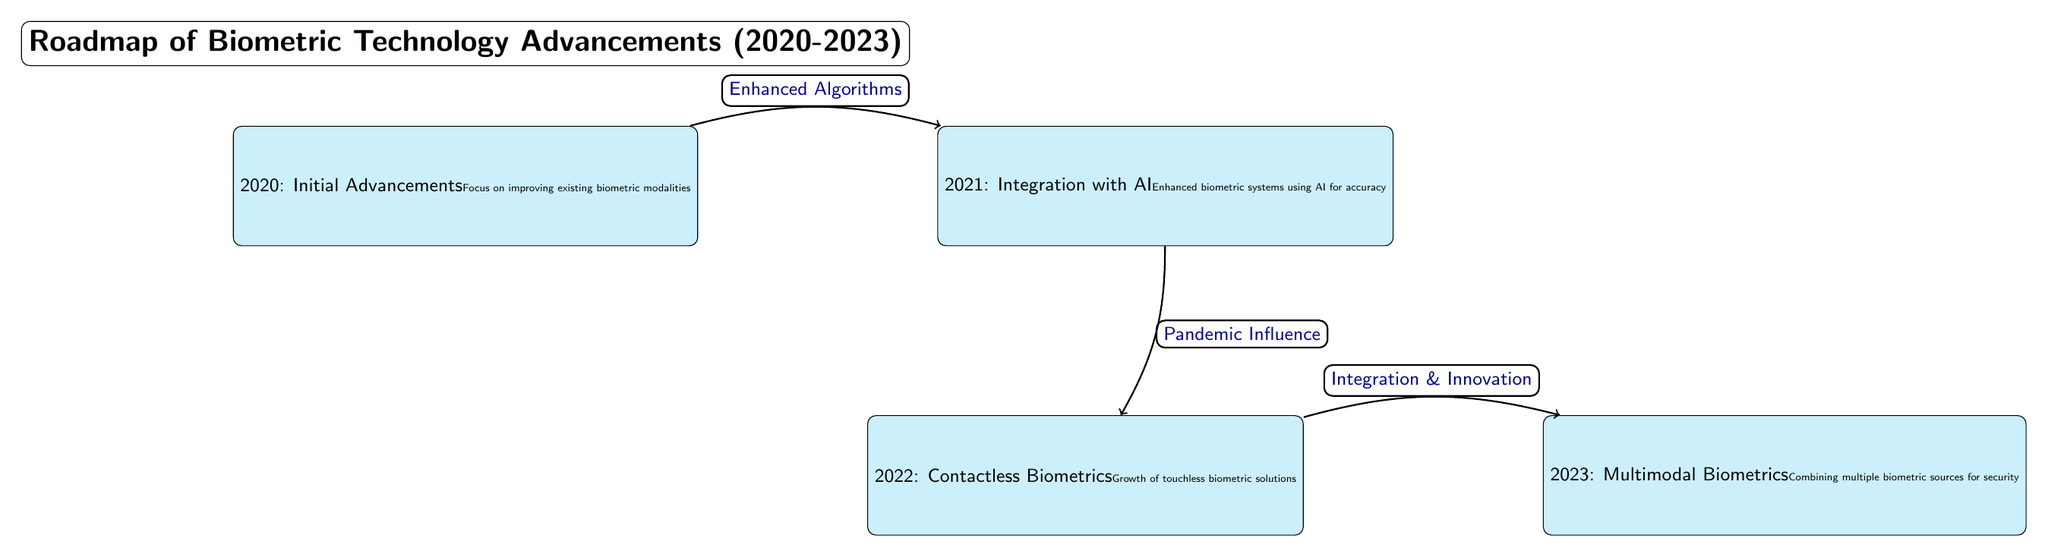What year is associated with the growth of touchless biometric solutions? The diagram states that the year 2022 is linked to the growth of contactless biometrics. It highlights this point explicitly under the node for 2022.
Answer: 2022 What is the main focus of advancements in 2020? According to the diagram, 2020's advancements are focused on improving existing biometric modalities. This is clearly stated in the node for that year.
Answer: Improving existing biometric modalities How many nodes are present in the diagram? The diagram has a total of four nodes representing the years 2020, 2021, 2022, and 2023, each indicating different advancements in biometric technology.
Answer: Four What was the influence behind the development of contactless biometrics in 2022? The diagram indicates that the pandemic influence was a significant factor that led to the development of contactless biometrics in 2022, as shown by the labeled edge from 2021 to 2022.
Answer: Pandemic Influence What is the relationship between the advancements made in 2021 and 2022? The diagram shows an edge pointing from 2021 to 2022 labeled as "Pandemic Influence," indicating that the advancements made in 2021 enabled or contributed to developments in 2022.
Answer: Pandemic Influence What type of biometric advancement is highlighted for the year 2023? The node for 2023 specifies that the focus is on multimodal biometrics, which involves combining multiple biometric sources for security. This detail is explicitly included in the node description.
Answer: Multimodal Biometrics How does the information from 2020 connect to the advancements in 2021? There is a directed edge from the year 2020 to 2021 labeled "Enhanced Algorithms." This indicates a direct impact of the improvements made in 2020 on the advancements in 2021.
Answer: Enhanced Algorithms What advancement trend is portrayed in the connection between 2022 and 2023? The diagram indicates that the transition from 2022 to 2023 is characterized by "Integration & Innovation," showcasing a direct relationship in growth between the two years.
Answer: Integration & Innovation 